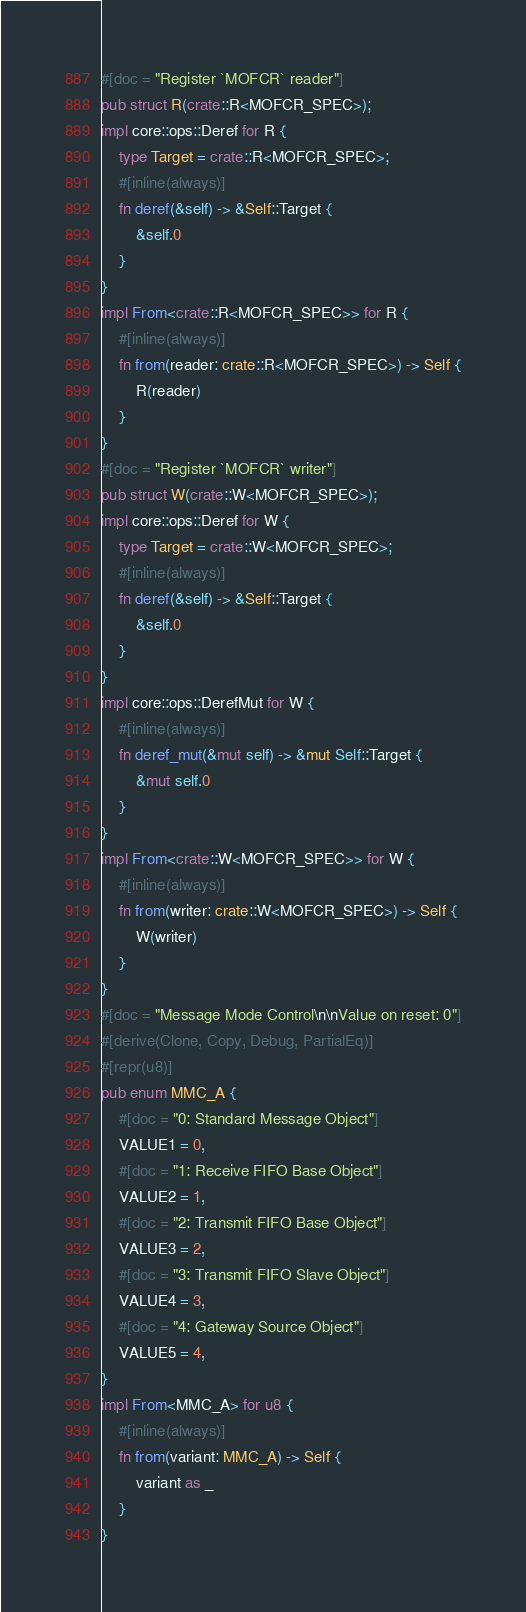<code> <loc_0><loc_0><loc_500><loc_500><_Rust_>#[doc = "Register `MOFCR` reader"]
pub struct R(crate::R<MOFCR_SPEC>);
impl core::ops::Deref for R {
    type Target = crate::R<MOFCR_SPEC>;
    #[inline(always)]
    fn deref(&self) -> &Self::Target {
        &self.0
    }
}
impl From<crate::R<MOFCR_SPEC>> for R {
    #[inline(always)]
    fn from(reader: crate::R<MOFCR_SPEC>) -> Self {
        R(reader)
    }
}
#[doc = "Register `MOFCR` writer"]
pub struct W(crate::W<MOFCR_SPEC>);
impl core::ops::Deref for W {
    type Target = crate::W<MOFCR_SPEC>;
    #[inline(always)]
    fn deref(&self) -> &Self::Target {
        &self.0
    }
}
impl core::ops::DerefMut for W {
    #[inline(always)]
    fn deref_mut(&mut self) -> &mut Self::Target {
        &mut self.0
    }
}
impl From<crate::W<MOFCR_SPEC>> for W {
    #[inline(always)]
    fn from(writer: crate::W<MOFCR_SPEC>) -> Self {
        W(writer)
    }
}
#[doc = "Message Mode Control\n\nValue on reset: 0"]
#[derive(Clone, Copy, Debug, PartialEq)]
#[repr(u8)]
pub enum MMC_A {
    #[doc = "0: Standard Message Object"]
    VALUE1 = 0,
    #[doc = "1: Receive FIFO Base Object"]
    VALUE2 = 1,
    #[doc = "2: Transmit FIFO Base Object"]
    VALUE3 = 2,
    #[doc = "3: Transmit FIFO Slave Object"]
    VALUE4 = 3,
    #[doc = "4: Gateway Source Object"]
    VALUE5 = 4,
}
impl From<MMC_A> for u8 {
    #[inline(always)]
    fn from(variant: MMC_A) -> Self {
        variant as _
    }
}</code> 